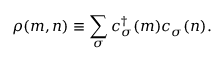<formula> <loc_0><loc_0><loc_500><loc_500>\rho ( m , n ) \equiv \sum _ { \sigma } c _ { \sigma } ^ { \dagger } ( m ) c _ { \sigma } ( n ) .</formula> 